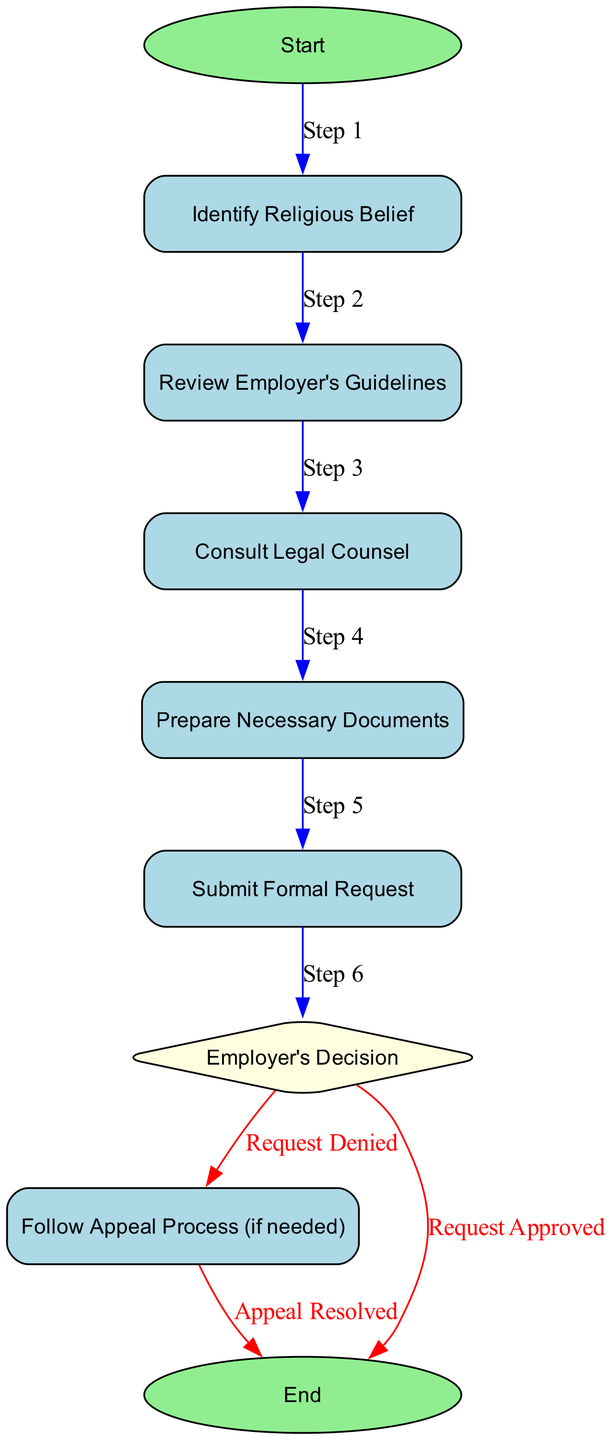What is the first step in the process? The first step in the process is indicated by the "Start" node, which leads to identifying the religious belief. The flow starts with this initial action.
Answer: Identify Religious Belief How many total nodes are there in the diagram? The diagram contains a total of nine nodes: Start, Identify Religious Belief, Review Employer's Guidelines, Consult Legal Counsel, Prepare Necessary Documents, Submit Formal Request, Employer's Decision, Follow Appeal Process (if needed), and End. Counting these gives a total of nine nodes.
Answer: Nine What action follows the submission of a formal request? After submitting a formal request, the next action according to the diagram is the employer's decision. This is the immediate next step in the flowchart.
Answer: Employer's Decision How many outcomes can result from the employer's decision? The employer's decision can result in two outcomes: 'Request Approved' or 'Request Denied', meaning there are two distinct paths based on this decision point.
Answer: Two If the request is denied, what process should be followed? If the request is denied, the process requires the individual to follow the appeal process. This is the action outlined as the next step in that case according to the diagram.
Answer: Follow Appeal Process (if needed) What is the shape of the node that represents the employer's decision? The employer's decision is represented by a diamond shape in the diagram, which signifies a decision point that can lead to multiple outcomes.
Answer: Diamond What happens if the appeal is resolved? If the appeal is resolved, the process concludes at the 'End' node, indicating that the process is complete after this step.
Answer: End What step requires the review of employer guidelines? The step that requires the review of employer's guidelines follows identifying the religious belief. This is the second step in the process as per the flow.
Answer: Review Employer's Guidelines What is the action taken before preparing necessary documents? Before preparing necessary documents, the action to consult legal counsel must be completed. This is the fourth step that precedes the document preparation.
Answer: Consult Legal Counsel 